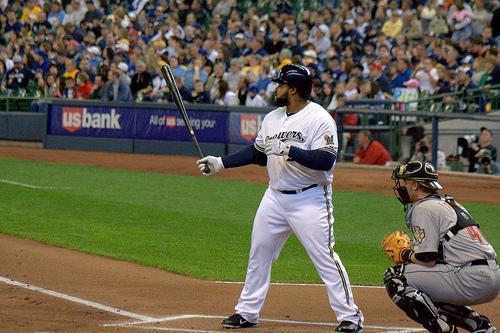How many bats do you see in the picture?
Give a very brief answer. 1. 